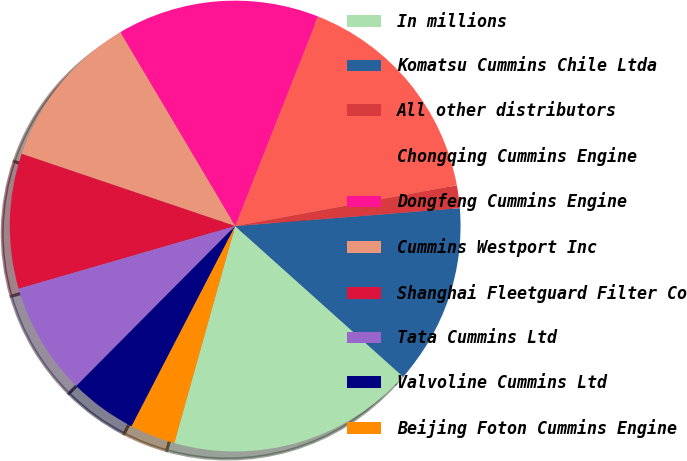Convert chart to OTSL. <chart><loc_0><loc_0><loc_500><loc_500><pie_chart><fcel>In millions<fcel>Komatsu Cummins Chile Ltda<fcel>All other distributors<fcel>Chongqing Cummins Engine<fcel>Dongfeng Cummins Engine<fcel>Cummins Westport Inc<fcel>Shanghai Fleetguard Filter Co<fcel>Tata Cummins Ltd<fcel>Valvoline Cummins Ltd<fcel>Beijing Foton Cummins Engine<nl><fcel>17.72%<fcel>12.9%<fcel>1.63%<fcel>16.11%<fcel>14.51%<fcel>11.29%<fcel>9.68%<fcel>8.07%<fcel>4.85%<fcel>3.24%<nl></chart> 